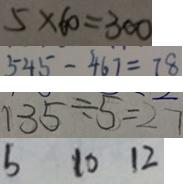<formula> <loc_0><loc_0><loc_500><loc_500>5 \times 6 0 = 3 0 0 
 5 4 5 - 4 6 7 = 7 8 
 1 3 5 \div 5 = 2 7 
 b 1 0 1 2</formula> 